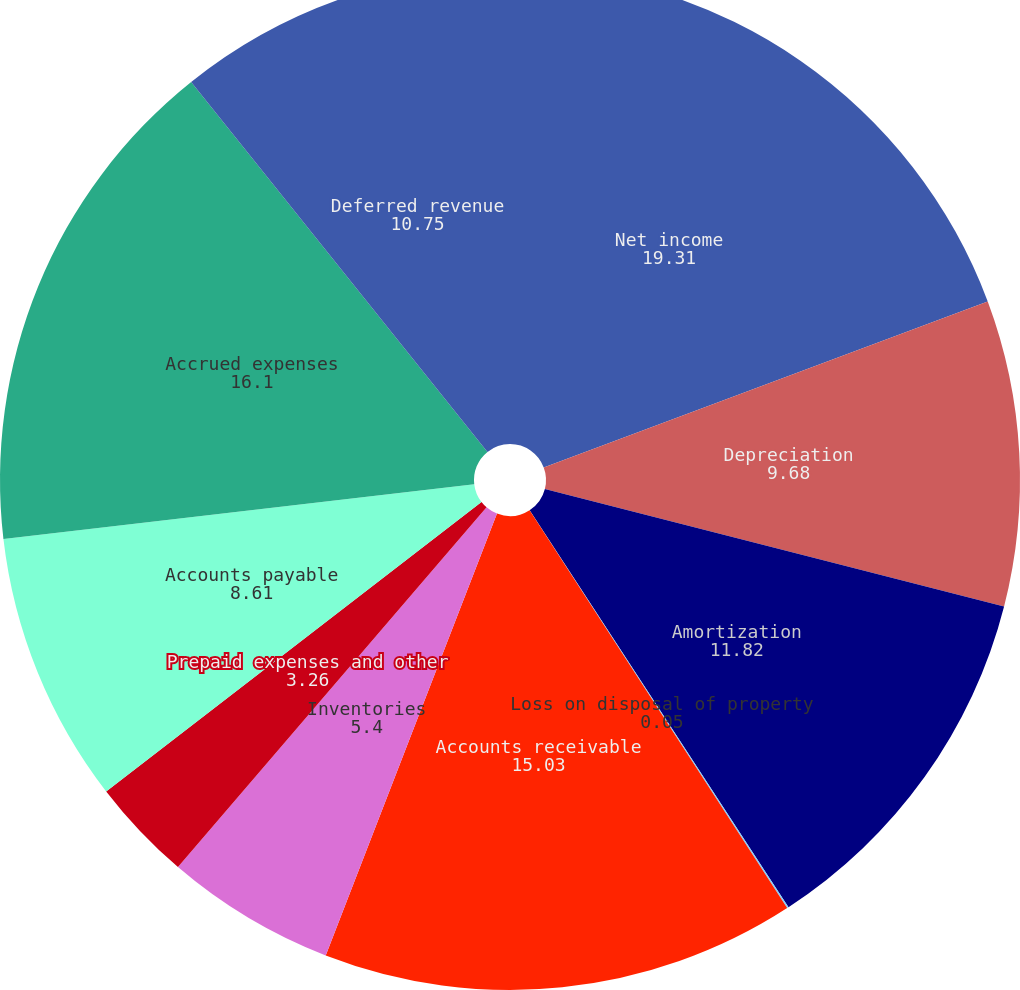<chart> <loc_0><loc_0><loc_500><loc_500><pie_chart><fcel>Net income<fcel>Depreciation<fcel>Amortization<fcel>Loss on disposal of property<fcel>Accounts receivable<fcel>Inventories<fcel>Prepaid expenses and other<fcel>Accounts payable<fcel>Accrued expenses<fcel>Deferred revenue<nl><fcel>19.31%<fcel>9.68%<fcel>11.82%<fcel>0.05%<fcel>15.03%<fcel>5.4%<fcel>3.26%<fcel>8.61%<fcel>16.1%<fcel>10.75%<nl></chart> 